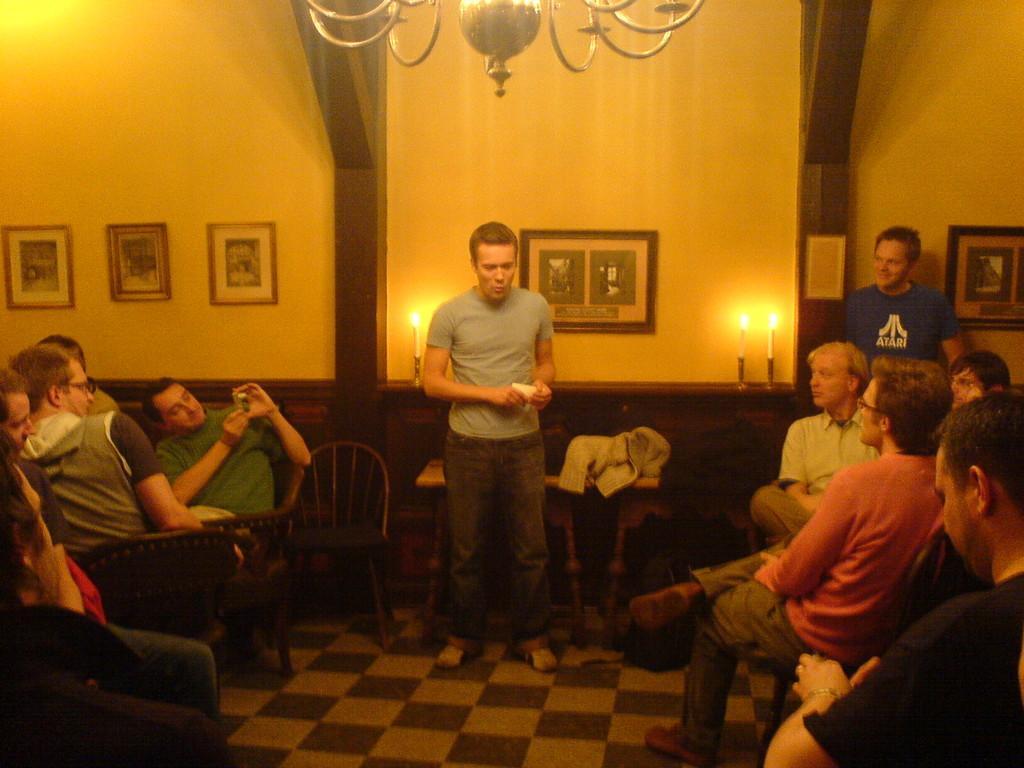Please provide a concise description of this image. in this image i can see a man standing at the center. at the left there are many people sitting. on the right there are people sitting and behind them there a man standing in blue t shirt. behind them there is a wall with many photo frames. above them there is a chandelier. 